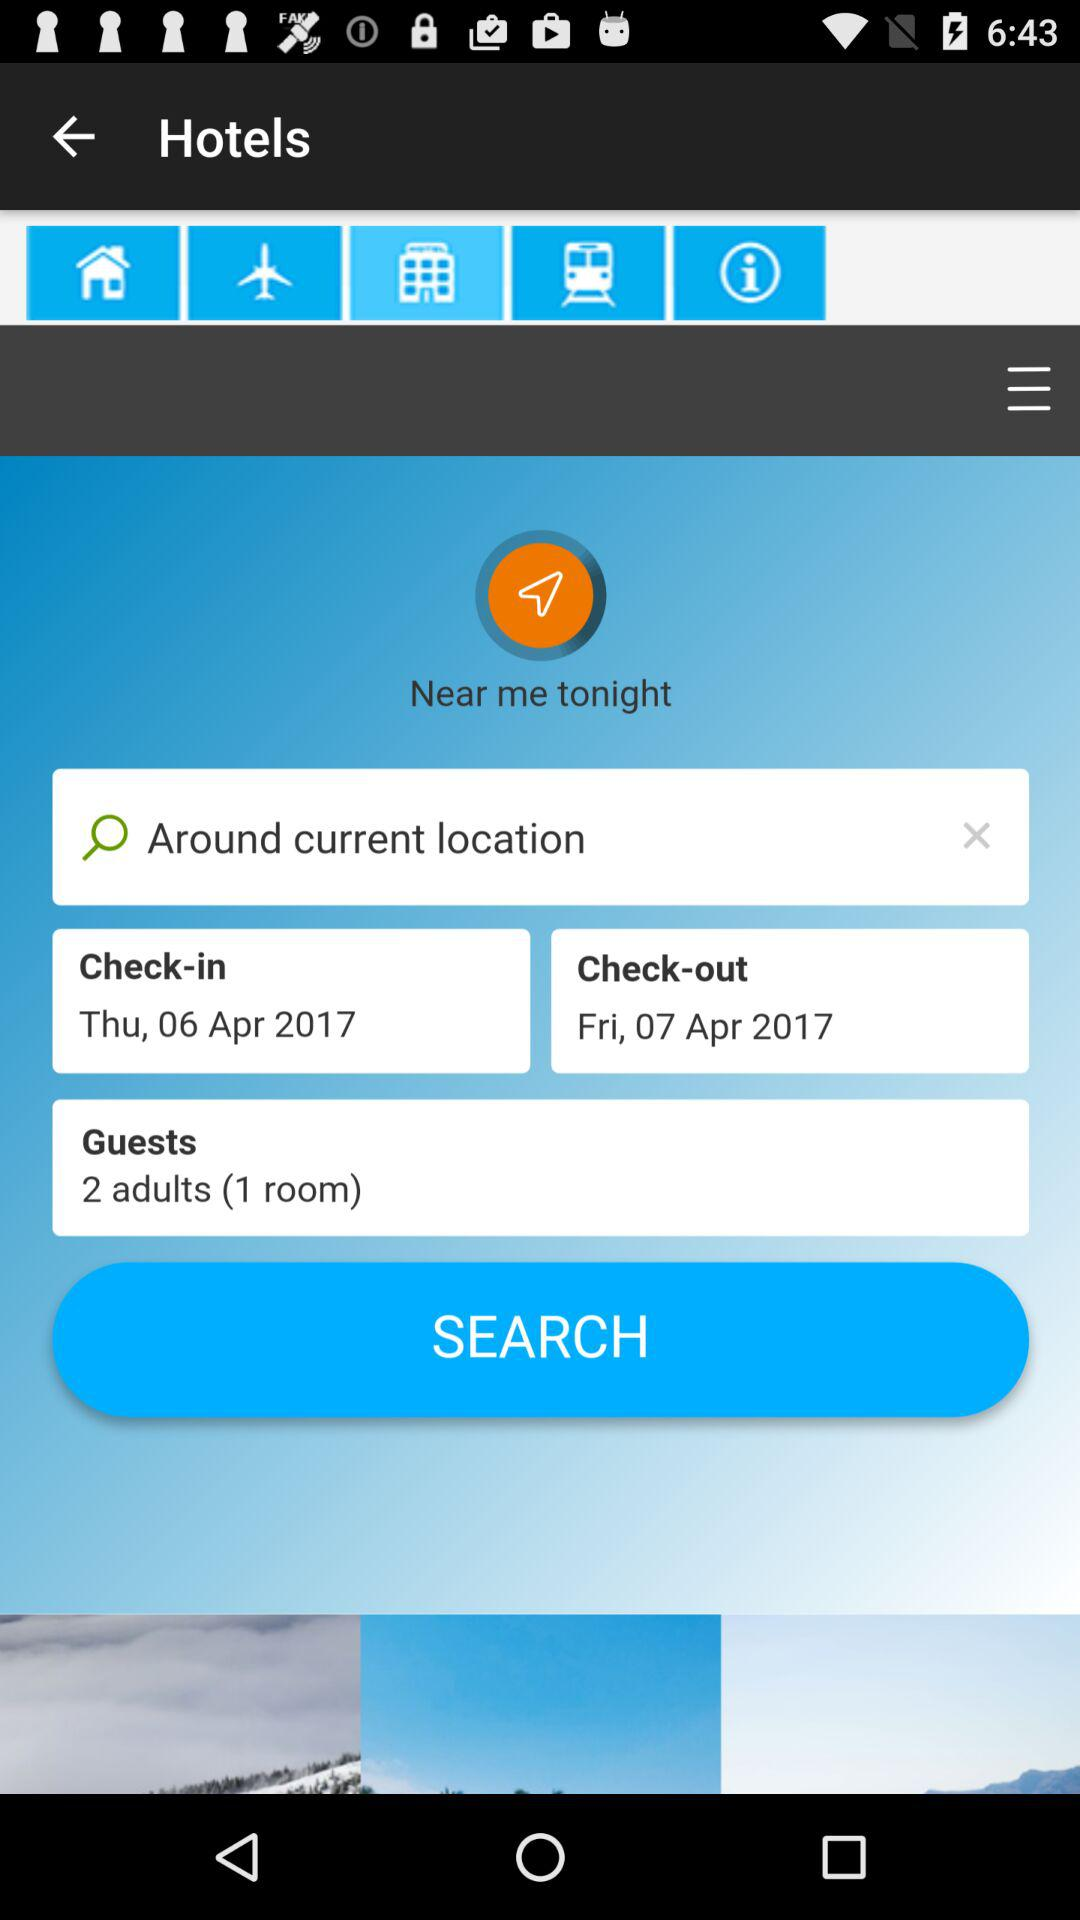How many days are between the check-in and check-out dates?
Answer the question using a single word or phrase. 1 